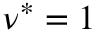<formula> <loc_0><loc_0><loc_500><loc_500>\nu ^ { * } = 1</formula> 